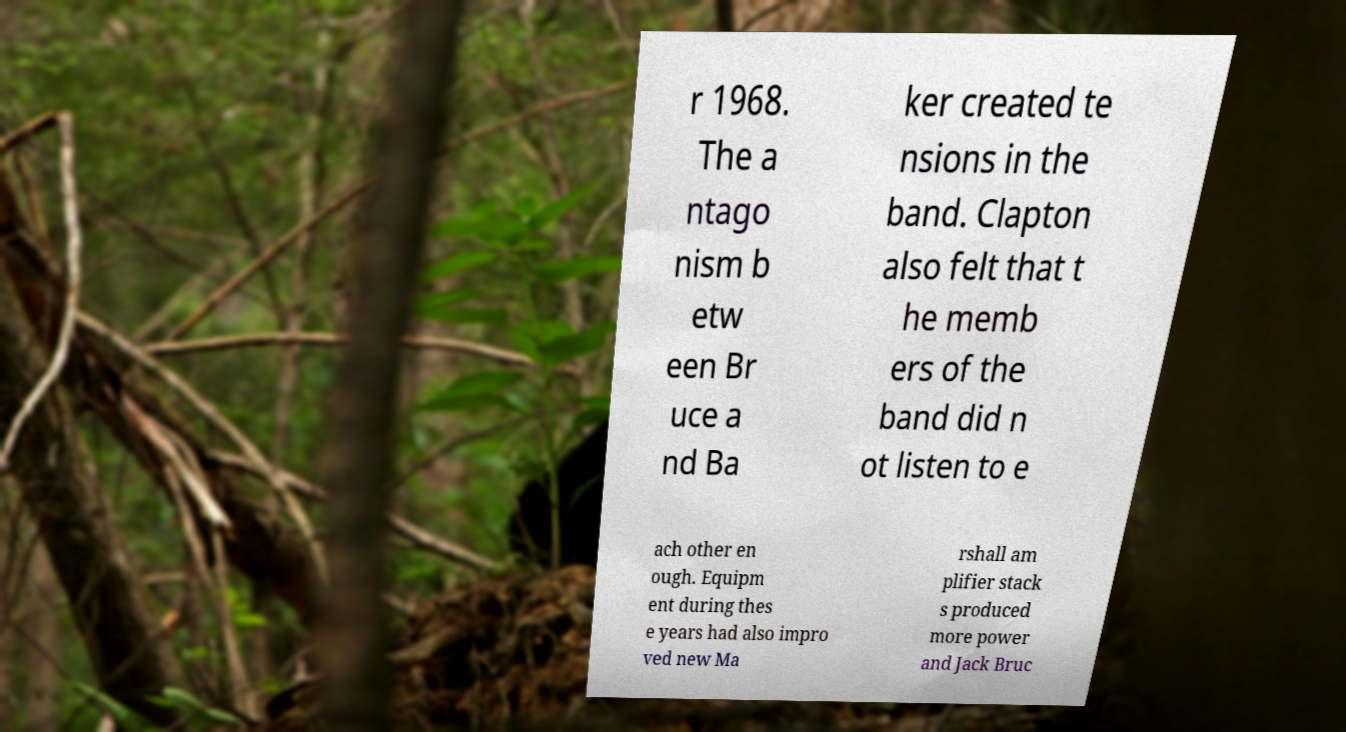Please identify and transcribe the text found in this image. r 1968. The a ntago nism b etw een Br uce a nd Ba ker created te nsions in the band. Clapton also felt that t he memb ers of the band did n ot listen to e ach other en ough. Equipm ent during thes e years had also impro ved new Ma rshall am plifier stack s produced more power and Jack Bruc 